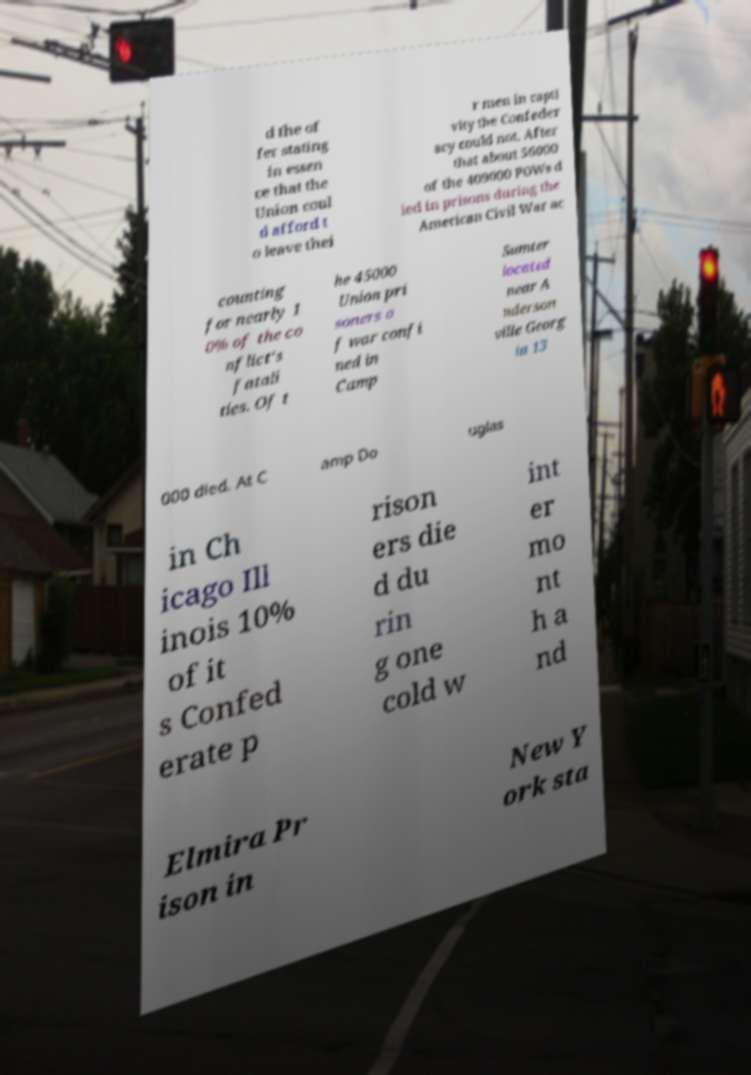Can you accurately transcribe the text from the provided image for me? d the of fer stating in essen ce that the Union coul d afford t o leave thei r men in capti vity the Confeder acy could not. After that about 56000 of the 409000 POWs d ied in prisons during the American Civil War ac counting for nearly 1 0% of the co nflict's fatali ties. Of t he 45000 Union pri soners o f war confi ned in Camp Sumter located near A nderson ville Georg ia 13 000 died. At C amp Do uglas in Ch icago Ill inois 10% of it s Confed erate p rison ers die d du rin g one cold w int er mo nt h a nd Elmira Pr ison in New Y ork sta 